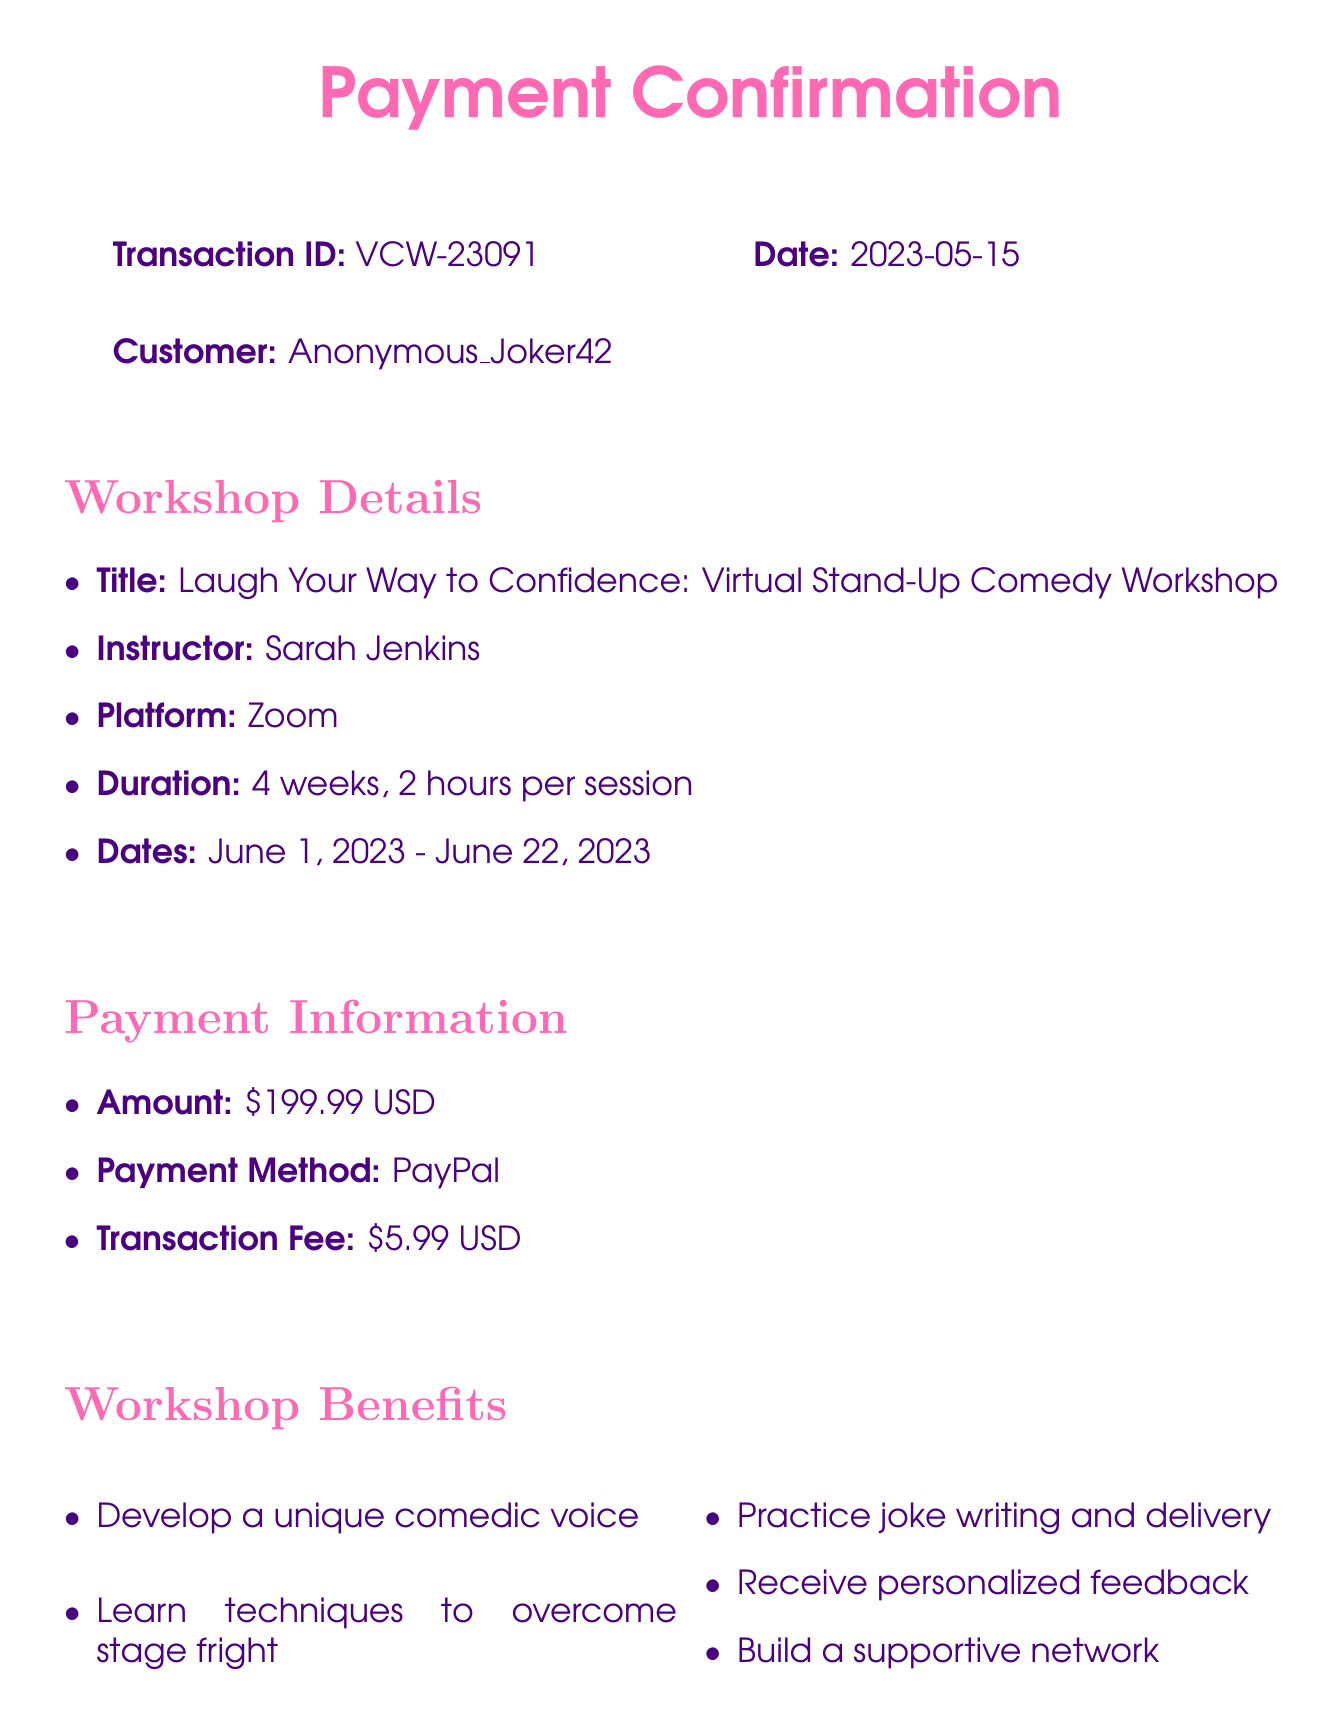What is the transaction ID? The transaction ID is a unique identifier for the transaction specified in the document.
Answer: VCW-23091 Who is the instructor for the workshop? The instructor's name is provided in the workshop details section of the document.
Answer: Sarah Jenkins What is the payment amount? The payment amount is mentioned in the payment information section.
Answer: 199.99 What is the duration of the workshop? The duration indicates how long the workshop will take place and is specified in the workshop details.
Answer: 4 weeks, 2 hours per session What is the refund policy? The refund policy explains the conditions under which a refund can be requested.
Answer: Full refund available within 7 days of the workshop start date What benefits come from attending the workshop? The benefits indicate what participants will gain from attending the workshop and are listed in the document.
Answer: Develop a unique comedic voice What are the technical requirements for the workshop? The technical requirements detail what participants need to successfully attend the workshop.
Answer: Stable internet connection, Webcam and microphone, Zoom app installed What is the platform used for the workshop? The document specifies the platform where the workshop will be delivered.
Answer: Zoom What is included in the course materials? The course materials section lists resources provided to the participants of the workshop.
Answer: Digital workbook: 'From Punchlines to Self-Confidence' 